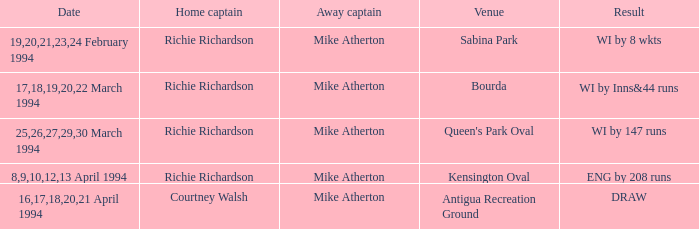When was there a happening at antigua recreation ground? 16,17,18,20,21 April 1994. 